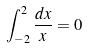<formula> <loc_0><loc_0><loc_500><loc_500>\int _ { - 2 } ^ { 2 } \frac { d x } { x } = 0</formula> 